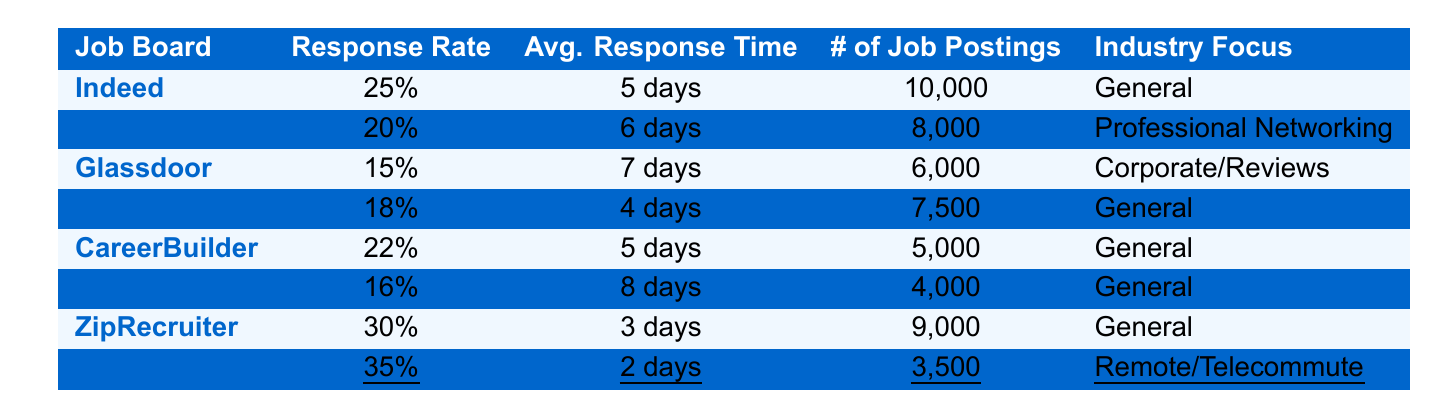What is the response rate of FlexJobs? The table indicates that the response rate of FlexJobs, which is underlined, is listed as 35%.
Answer: 35% Which job board has the highest response rate? In the table, FlexJobs has the highest response rate at 35%.
Answer: FlexJobs How long does it take for responses from ZipRecruiter? The average time to response for ZipRecruiter, as provided in the table, is 3 days.
Answer: 3 days What is the average response time across all job boards? To find the average response time, add up the individual response times converted to days: (5 + 6 + 7 + 4 + 5 + 8 + 3 + 2) = 40 days, then divide by the total number of job boards (8), which equals 5 days.
Answer: 5 days Is the response rate of LinkedIn higher than that of Glassdoor? According to the table, LinkedIn has a response rate of 20%, while Glassdoor has 15%, indicating that LinkedIn's response rate is higher.
Answer: Yes Which job board has the least number of job postings? The least number of job postings in the table is for FlexJobs with 3,500 postings.
Answer: FlexJobs What is the difference in response rates between Indeed and CareerBuilder? Indeed has a response rate of 25% while CareerBuilder’s is 22%. The difference is 25% - 22% = 3%.
Answer: 3% Does Glassdoor focus on general job types? The industry focus of Glassdoor is listed as Corporate/Reviews in the table, which means it does not focus on general job types.
Answer: No If you combine the number of job postings from Monster and SimplyHired, how many total postings do you have? Adding the number of job postings from Monster (7,500) and SimplyHired (4,000) gives a total of 7,500 + 4,000 = 11,500 postings.
Answer: 11,500 Which job board has a response rate lower than 20%? The job boards with response rates lower than 20%, as seen in the table, are Glassdoor (15%) and SimplyHired (16%).
Answer: Glassdoor and SimplyHired 